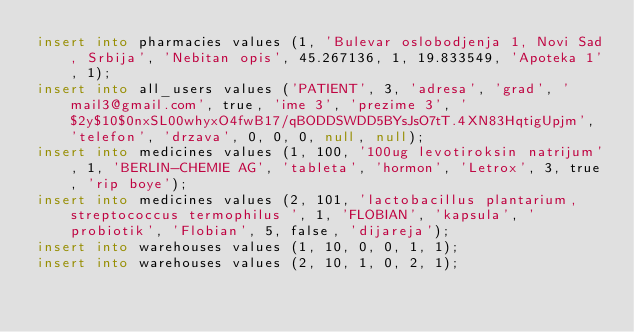Convert code to text. <code><loc_0><loc_0><loc_500><loc_500><_SQL_>insert into pharmacies values (1, 'Bulevar oslobodjenja 1, Novi Sad, Srbija', 'Nebitan opis', 45.267136, 1, 19.833549, 'Apoteka 1', 1);
insert into all_users values ('PATIENT', 3, 'adresa', 'grad', 'mail3@gmail.com', true, 'ime 3', 'prezime 3', '$2y$10$0nxSL00whyxO4fwB17/qBODDSWDD5BYsJsO7tT.4XN83HqtigUpjm', 'telefon', 'drzava', 0, 0, 0, null, null);
insert into medicines values (1, 100, '100ug levotiroksin natrijum', 1, 'BERLIN-CHEMIE AG', 'tableta', 'hormon', 'Letrox', 3, true, 'rip boye');
insert into medicines values (2, 101, 'lactobacillus plantarium, streptococcus termophilus ', 1, 'FLOBIAN', 'kapsula', 'probiotik', 'Flobian', 5, false, 'dijareja');
insert into warehouses values (1, 10, 0, 0, 1, 1);
insert into warehouses values (2, 10, 1, 0, 2, 1);</code> 